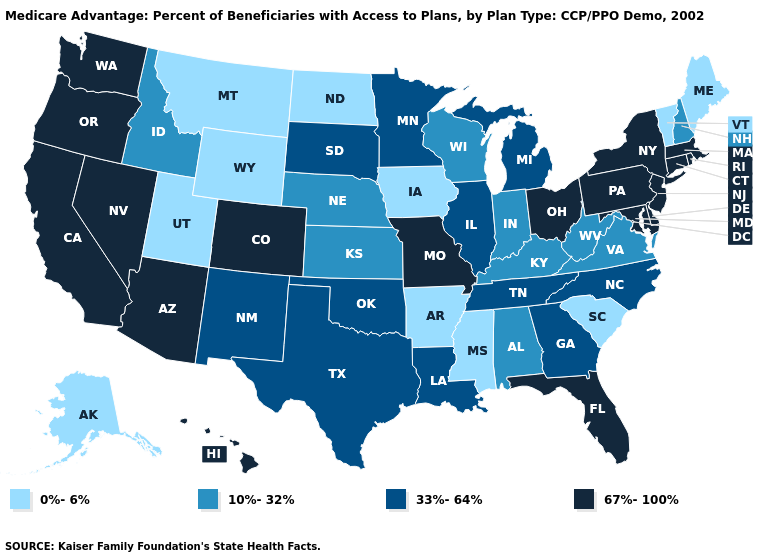Among the states that border California , which have the lowest value?
Quick response, please. Arizona, Nevada, Oregon. What is the value of Oklahoma?
Give a very brief answer. 33%-64%. Which states have the lowest value in the USA?
Quick response, please. Alaska, Arkansas, Iowa, Maine, Mississippi, Montana, North Dakota, South Carolina, Utah, Vermont, Wyoming. Among the states that border Illinois , does Iowa have the lowest value?
Keep it brief. Yes. Does the first symbol in the legend represent the smallest category?
Short answer required. Yes. What is the highest value in the USA?
Give a very brief answer. 67%-100%. What is the highest value in the South ?
Answer briefly. 67%-100%. Does the first symbol in the legend represent the smallest category?
Short answer required. Yes. What is the value of Iowa?
Quick response, please. 0%-6%. Among the states that border Nevada , which have the highest value?
Write a very short answer. Arizona, California, Oregon. How many symbols are there in the legend?
Write a very short answer. 4. What is the lowest value in states that border Nebraska?
Write a very short answer. 0%-6%. Name the states that have a value in the range 67%-100%?
Short answer required. Arizona, California, Colorado, Connecticut, Delaware, Florida, Hawaii, Massachusetts, Maryland, Missouri, New Jersey, Nevada, New York, Ohio, Oregon, Pennsylvania, Rhode Island, Washington. Does Illinois have a lower value than Delaware?
Answer briefly. Yes. Among the states that border Arkansas , which have the lowest value?
Be succinct. Mississippi. 